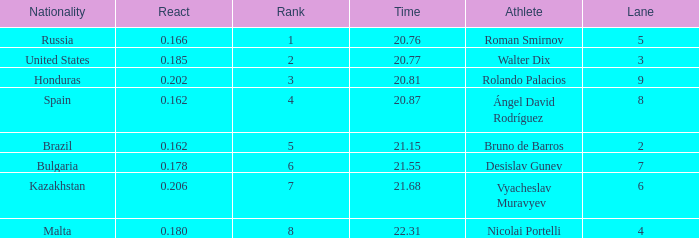Could you help me parse every detail presented in this table? {'header': ['Nationality', 'React', 'Rank', 'Time', 'Athlete', 'Lane'], 'rows': [['Russia', '0.166', '1', '20.76', 'Roman Smirnov', '5'], ['United States', '0.185', '2', '20.77', 'Walter Dix', '3'], ['Honduras', '0.202', '3', '20.81', 'Rolando Palacios', '9'], ['Spain', '0.162', '4', '20.87', 'Ángel David Rodríguez', '8'], ['Brazil', '0.162', '5', '21.15', 'Bruno de Barros', '2'], ['Bulgaria', '0.178', '6', '21.55', 'Desislav Gunev', '7'], ['Kazakhstan', '0.206', '7', '21.68', 'Vyacheslav Muravyev', '6'], ['Malta', '0.180', '8', '22.31', 'Nicolai Portelli', '4']]} What's Brazil's lane with a time less than 21.15? None. 